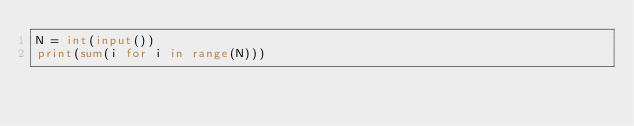Convert code to text. <code><loc_0><loc_0><loc_500><loc_500><_Python_>N = int(input())
print(sum(i for i in range(N)))
</code> 